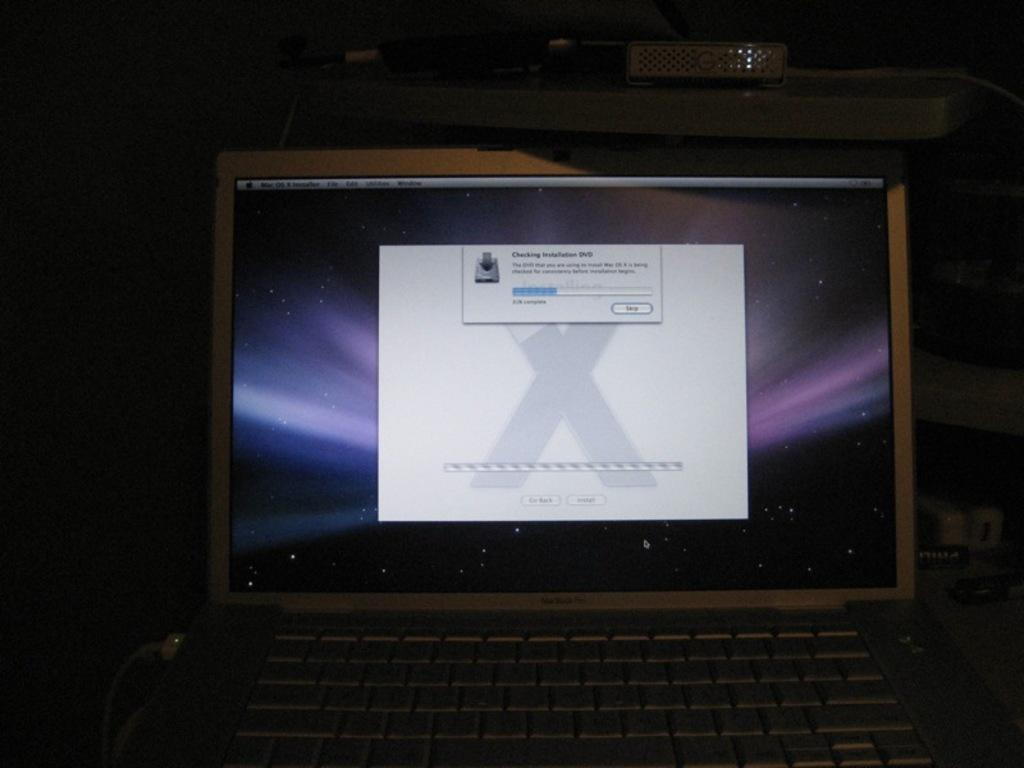<image>
Describe the image concisely. An on screen message providing information on a process. 